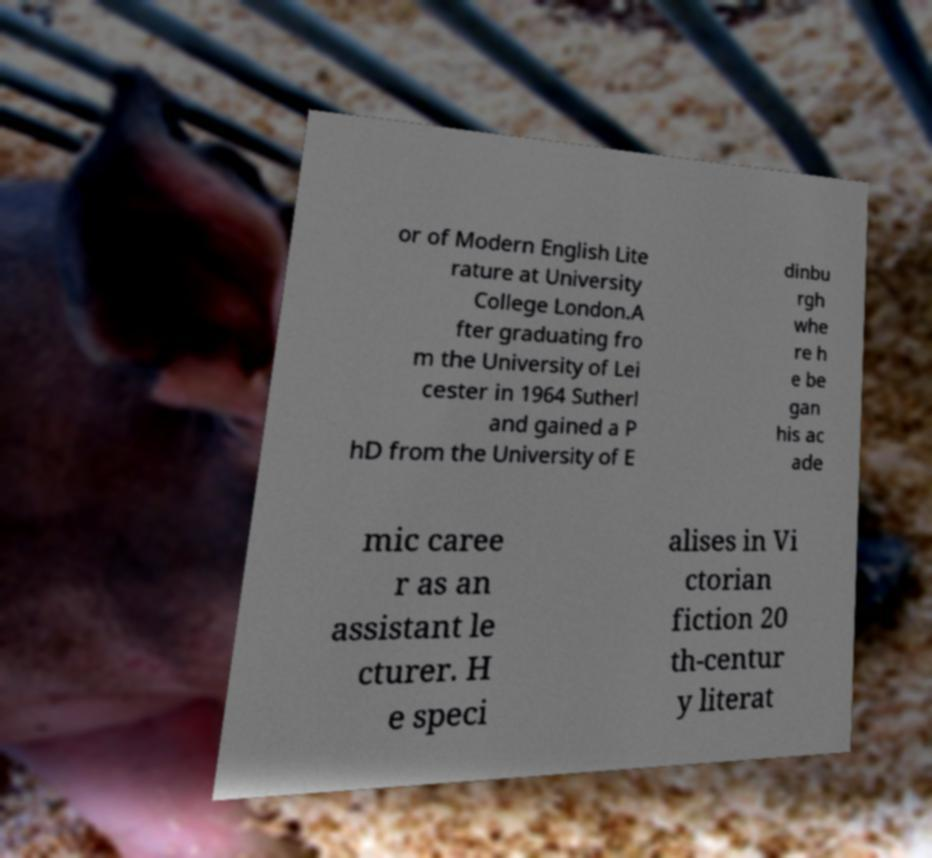For documentation purposes, I need the text within this image transcribed. Could you provide that? or of Modern English Lite rature at University College London.A fter graduating fro m the University of Lei cester in 1964 Sutherl and gained a P hD from the University of E dinbu rgh whe re h e be gan his ac ade mic caree r as an assistant le cturer. H e speci alises in Vi ctorian fiction 20 th-centur y literat 